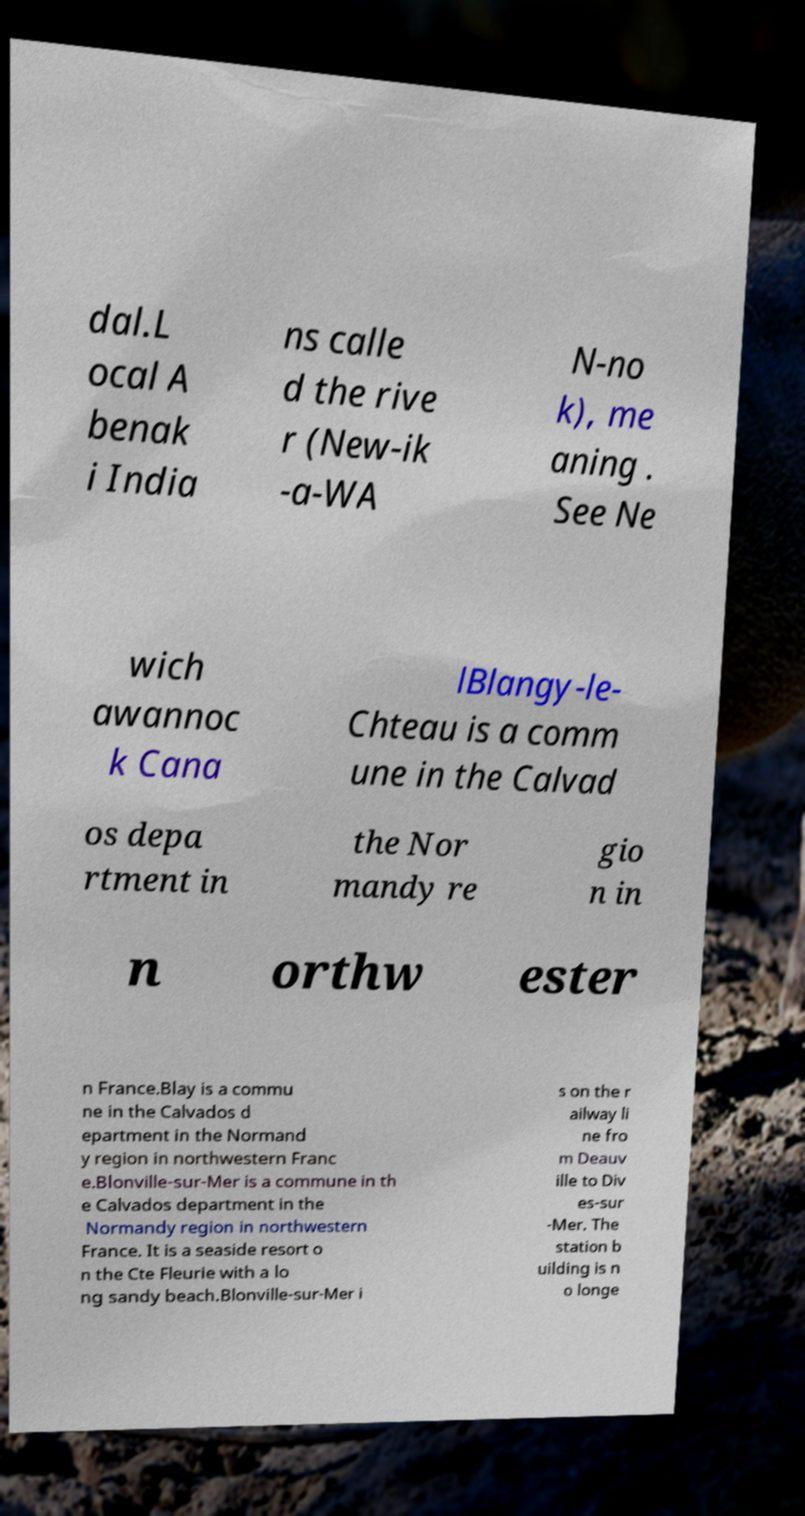Could you assist in decoding the text presented in this image and type it out clearly? dal.L ocal A benak i India ns calle d the rive r (New-ik -a-WA N-no k), me aning . See Ne wich awannoc k Cana lBlangy-le- Chteau is a comm une in the Calvad os depa rtment in the Nor mandy re gio n in n orthw ester n France.Blay is a commu ne in the Calvados d epartment in the Normand y region in northwestern Franc e.Blonville-sur-Mer is a commune in th e Calvados department in the Normandy region in northwestern France. It is a seaside resort o n the Cte Fleurie with a lo ng sandy beach.Blonville-sur-Mer i s on the r ailway li ne fro m Deauv ille to Div es-sur -Mer. The station b uilding is n o longe 